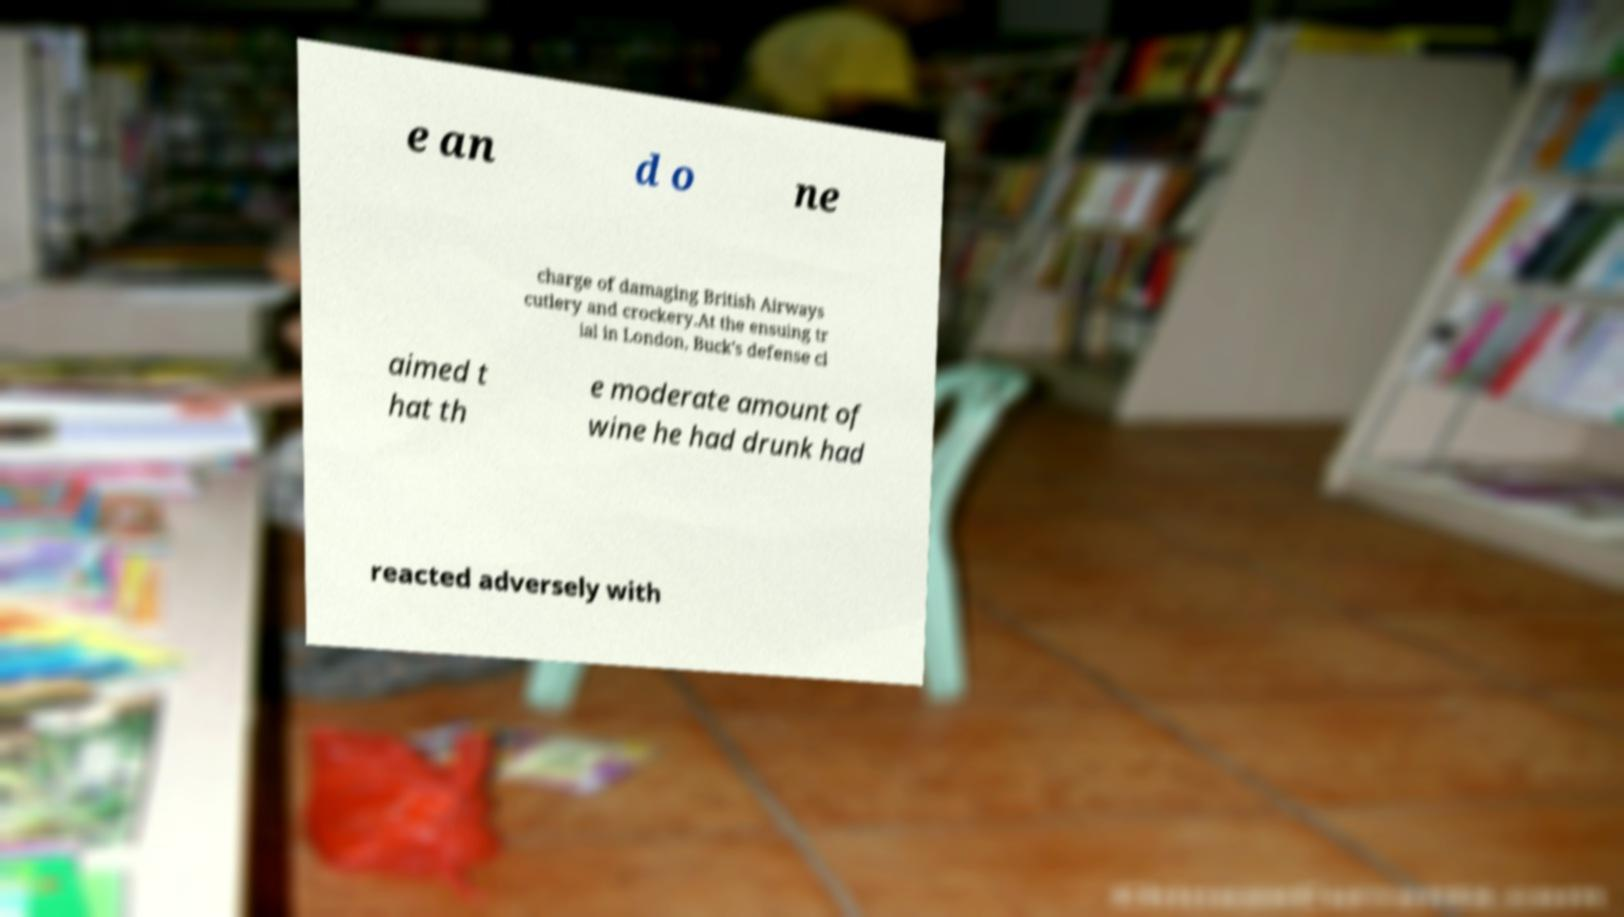For documentation purposes, I need the text within this image transcribed. Could you provide that? e an d o ne charge of damaging British Airways cutlery and crockery.At the ensuing tr ial in London, Buck's defense cl aimed t hat th e moderate amount of wine he had drunk had reacted adversely with 